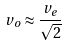Convert formula to latex. <formula><loc_0><loc_0><loc_500><loc_500>v _ { o } \approx \frac { v _ { e } } { \sqrt { 2 } }</formula> 